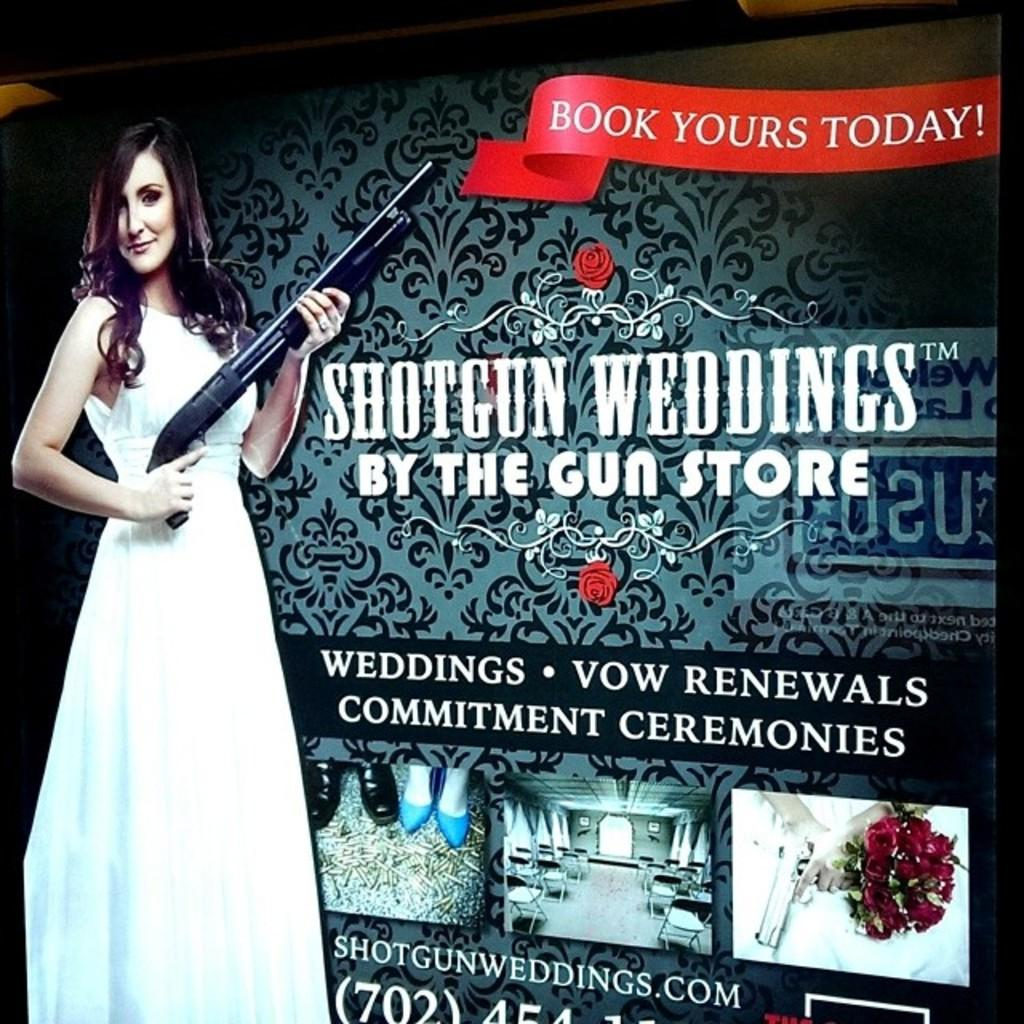What is the main feature of the image? There is a banner in the image. What is depicted on the banner? The banner has an image of a woman holding a gun. How is the woman holding the gun? The woman is holding the gun in her hand. What else can be seen on the banner besides the image? There is text written beside the image. Are there any other images on the banner? There are other images below the main image. How many apples are being held by the person in the image? There is no person holding apples in the image; it features a woman holding a gun. What type of brick is being used to build the structure in the image? There is no structure or brick present in the image; it only features a banner with an image of a woman holding a gun. 